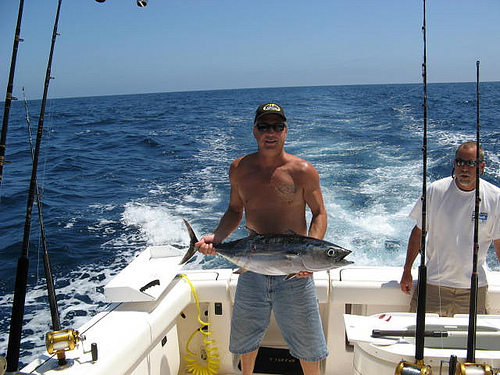<image>
Is the fish on the boat? Yes. Looking at the image, I can see the fish is positioned on top of the boat, with the boat providing support. 